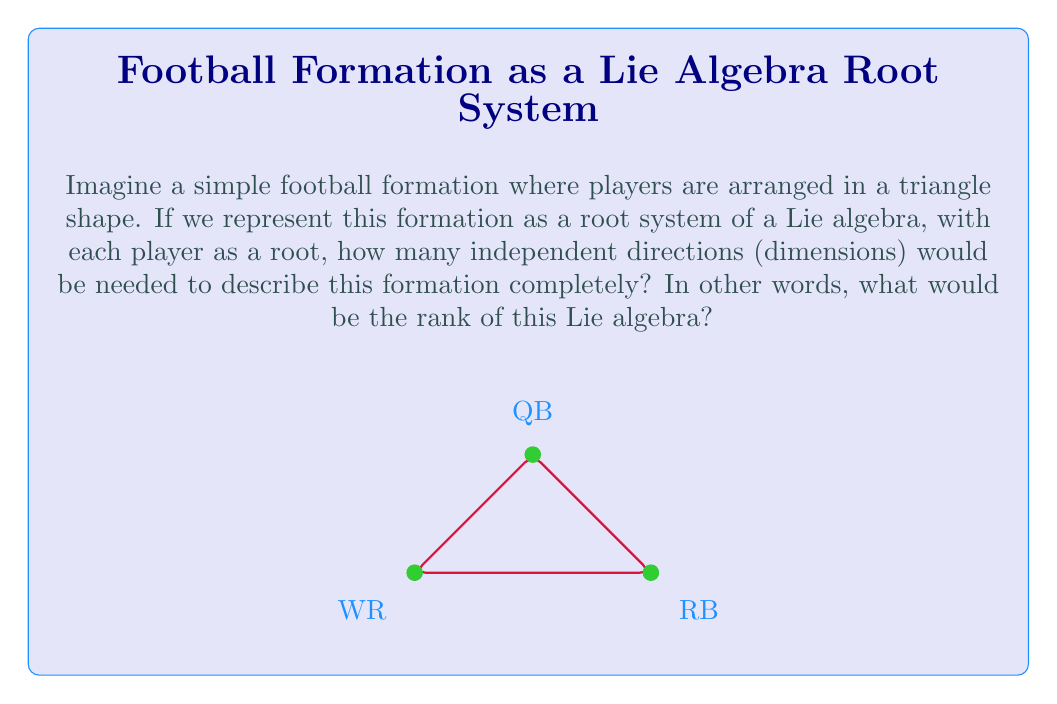Provide a solution to this math problem. Let's approach this step-by-step:

1) In Lie algebra theory, the rank of a simple Lie algebra is equal to the dimension of its Cartan subalgebra, which is also the number of simple roots in its root system.

2) In our football analogy, each player represents a root in the root system. The formation shown is a triangle, which is a two-dimensional shape.

3) To describe the position of any player in this formation, we need exactly two independent directions or coordinates. For example:
   - We could use "forward-backward" and "left-right" directions.
   - Or we could use the distances from two of the corners of the field.

4) In mathematical terms, we need a 2-dimensional vector space to describe all possible positions in this formation.

5) Therefore, the root system of this "football Lie algebra" would be embedded in a 2-dimensional space.

6) The dimension of this space is equal to the rank of the corresponding Lie algebra.

Thus, the rank of this simple Lie algebra, represented by our football formation, is 2.
Answer: 2 